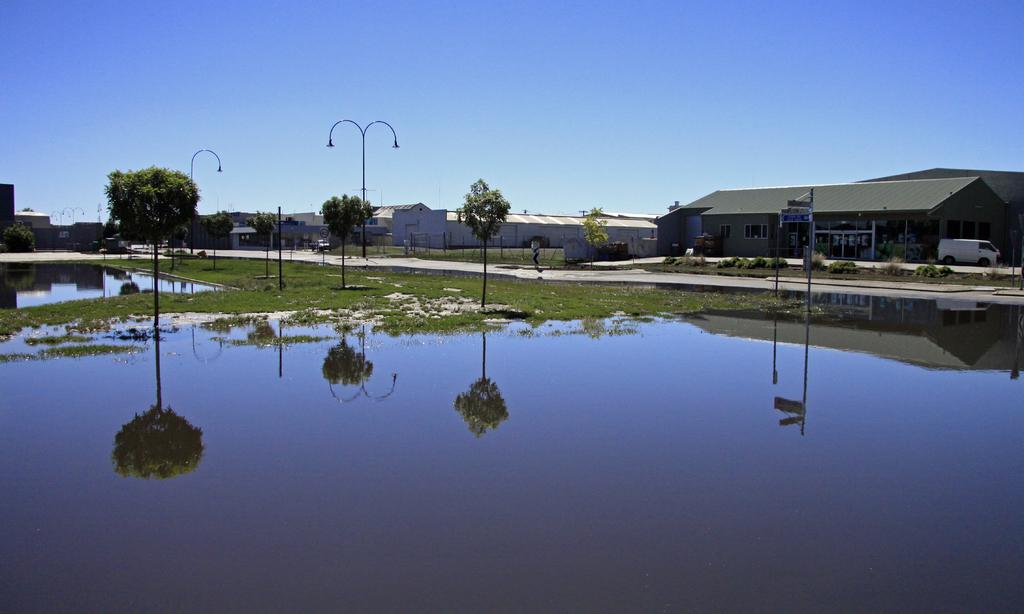What type of structures can be seen in the image? There are houses in the image. What objects are present in the image that might be related to electricity or communication? There are poles and lights visible in the image. What type of natural environment can be seen in the image? The ground with grass and trees are visible in the image. What body of water is present in the image? There is water visible in the image. What is visible in the sky in the image? The sky is visible in the image. What can be observed on the water's surface in the image? There are reflections on the water in the image. What type of boat can be seen in the image? There is no boat present in the image. What is the taste of the geese in the image? There are no geese present in the image, and therefore no taste can be determined. 